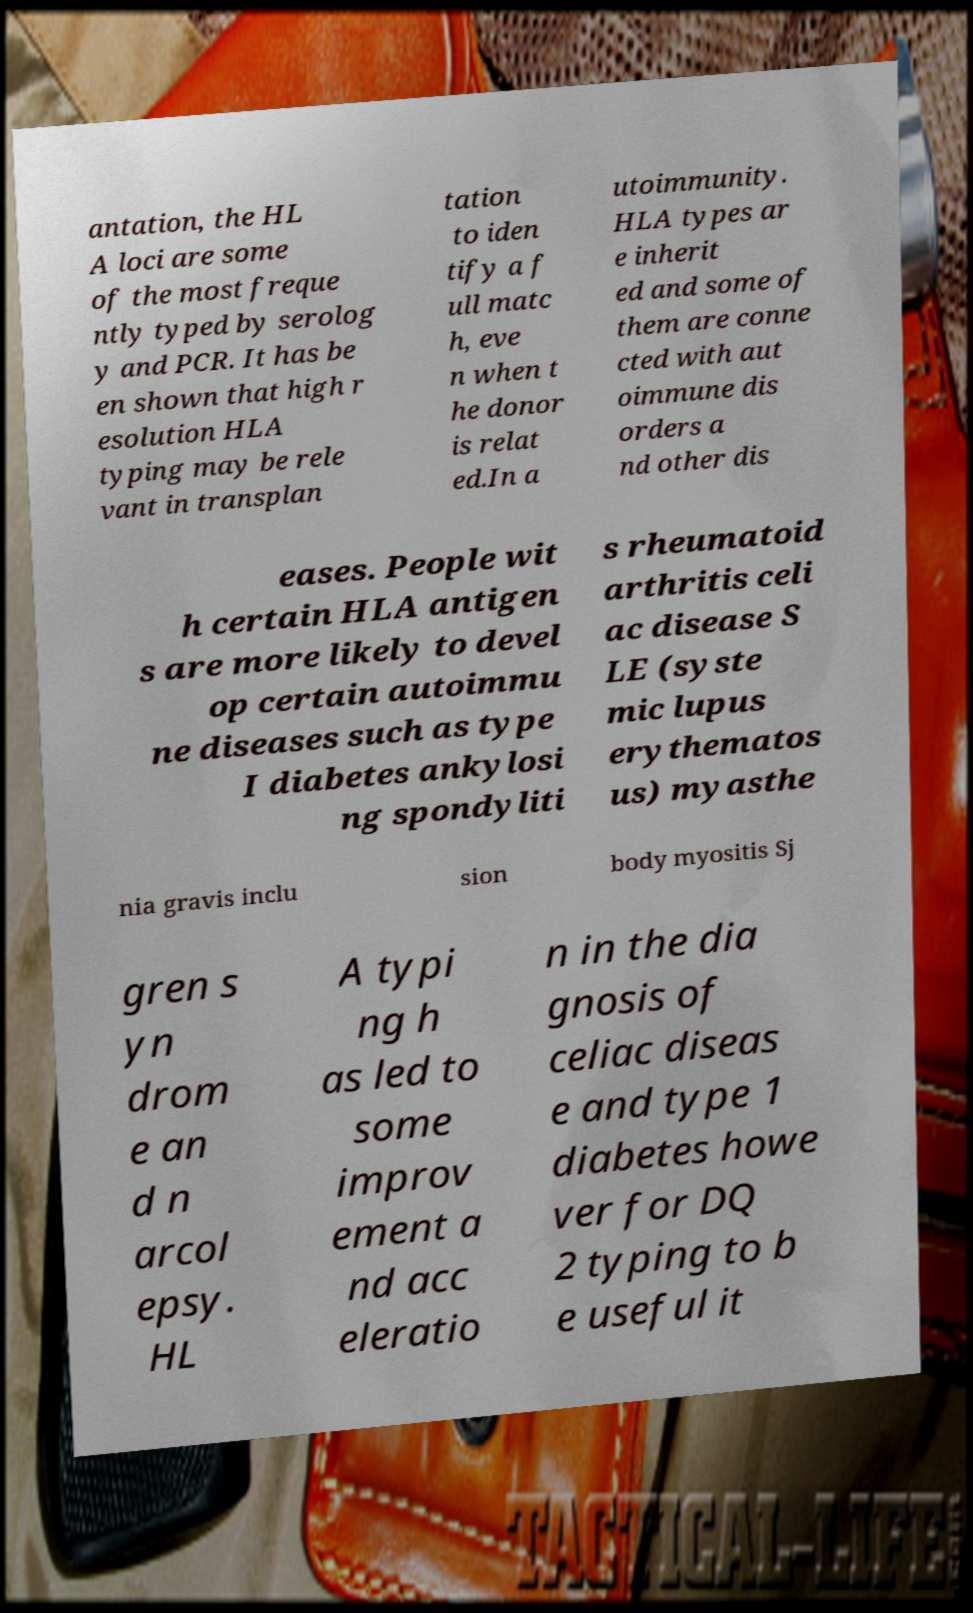Please identify and transcribe the text found in this image. antation, the HL A loci are some of the most freque ntly typed by serolog y and PCR. It has be en shown that high r esolution HLA typing may be rele vant in transplan tation to iden tify a f ull matc h, eve n when t he donor is relat ed.In a utoimmunity. HLA types ar e inherit ed and some of them are conne cted with aut oimmune dis orders a nd other dis eases. People wit h certain HLA antigen s are more likely to devel op certain autoimmu ne diseases such as type I diabetes ankylosi ng spondyliti s rheumatoid arthritis celi ac disease S LE (syste mic lupus erythematos us) myasthe nia gravis inclu sion body myositis Sj gren s yn drom e an d n arcol epsy. HL A typi ng h as led to some improv ement a nd acc eleratio n in the dia gnosis of celiac diseas e and type 1 diabetes howe ver for DQ 2 typing to b e useful it 